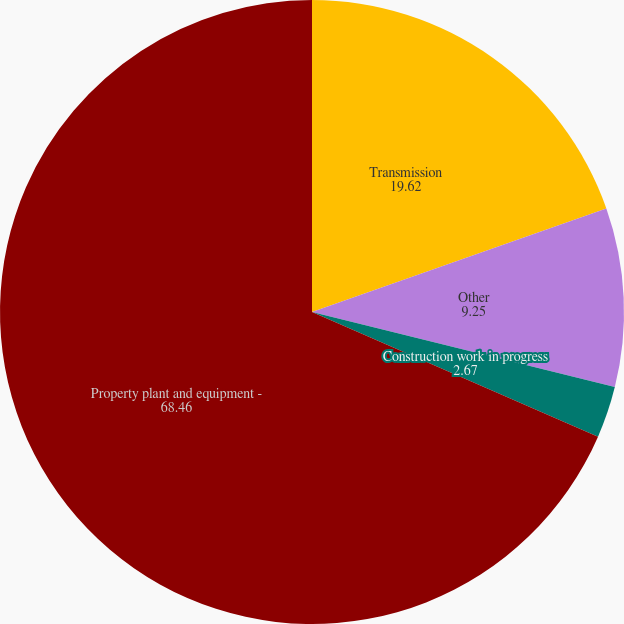<chart> <loc_0><loc_0><loc_500><loc_500><pie_chart><fcel>Transmission<fcel>Other<fcel>Construction work in progress<fcel>Property plant and equipment -<nl><fcel>19.62%<fcel>9.25%<fcel>2.67%<fcel>68.46%<nl></chart> 